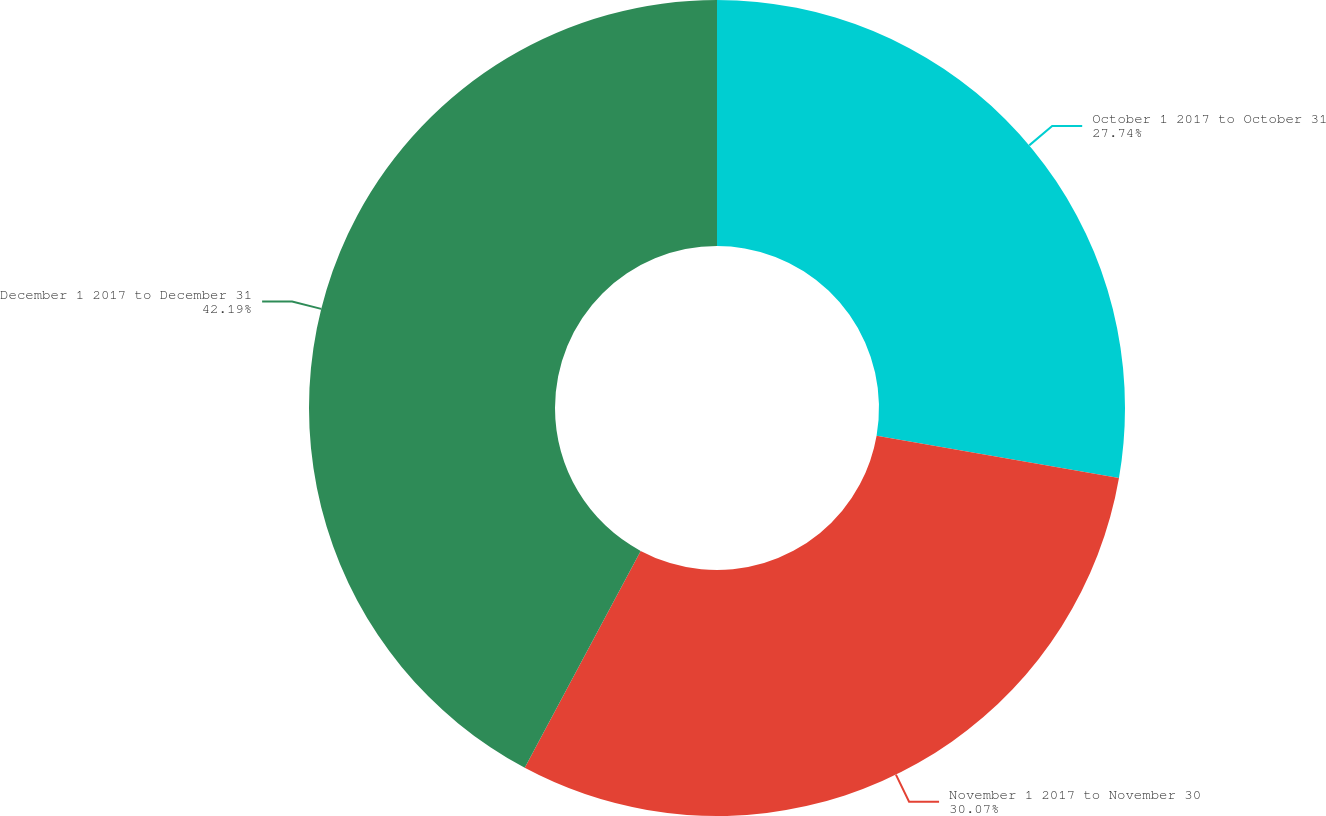Convert chart. <chart><loc_0><loc_0><loc_500><loc_500><pie_chart><fcel>October 1 2017 to October 31<fcel>November 1 2017 to November 30<fcel>December 1 2017 to December 31<nl><fcel>27.74%<fcel>30.07%<fcel>42.19%<nl></chart> 